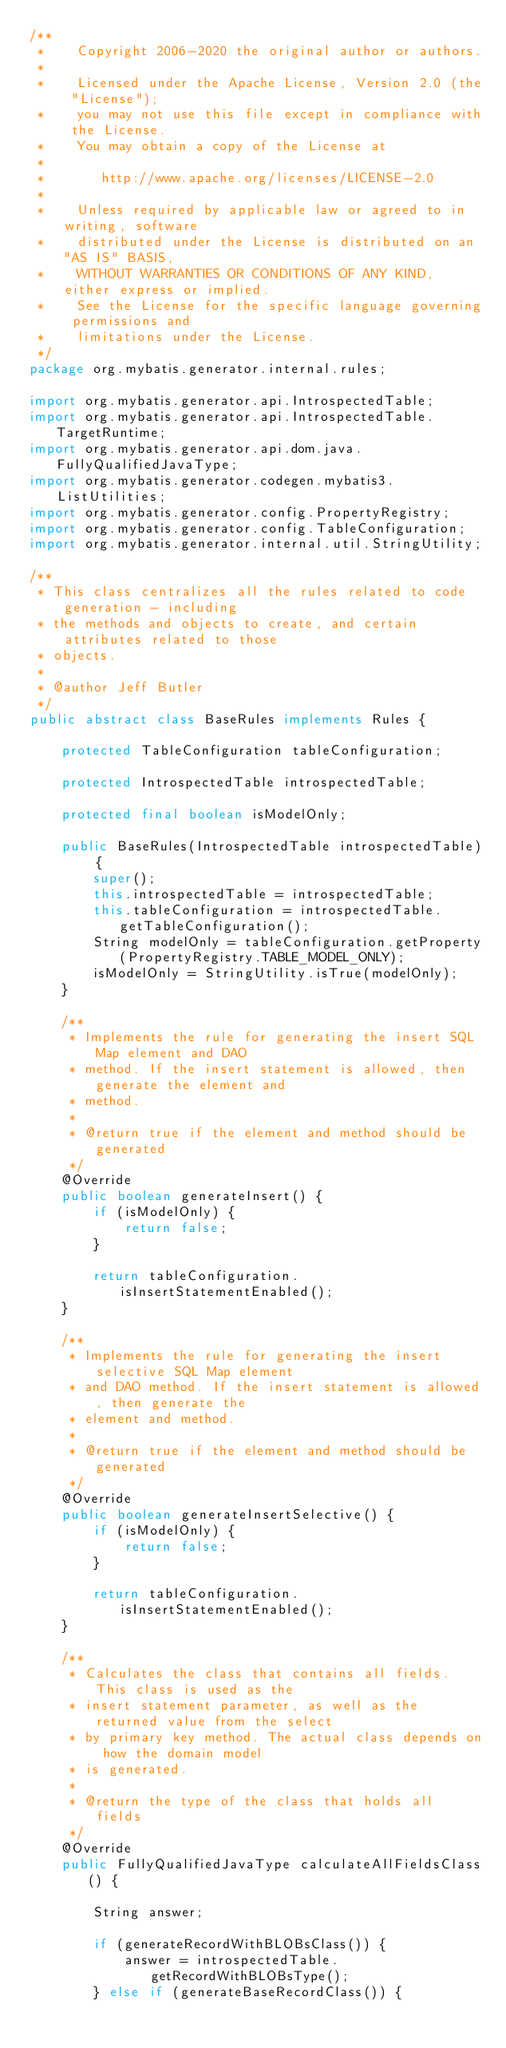Convert code to text. <code><loc_0><loc_0><loc_500><loc_500><_Java_>/**
 *    Copyright 2006-2020 the original author or authors.
 *
 *    Licensed under the Apache License, Version 2.0 (the "License");
 *    you may not use this file except in compliance with the License.
 *    You may obtain a copy of the License at
 *
 *       http://www.apache.org/licenses/LICENSE-2.0
 *
 *    Unless required by applicable law or agreed to in writing, software
 *    distributed under the License is distributed on an "AS IS" BASIS,
 *    WITHOUT WARRANTIES OR CONDITIONS OF ANY KIND, either express or implied.
 *    See the License for the specific language governing permissions and
 *    limitations under the License.
 */
package org.mybatis.generator.internal.rules;

import org.mybatis.generator.api.IntrospectedTable;
import org.mybatis.generator.api.IntrospectedTable.TargetRuntime;
import org.mybatis.generator.api.dom.java.FullyQualifiedJavaType;
import org.mybatis.generator.codegen.mybatis3.ListUtilities;
import org.mybatis.generator.config.PropertyRegistry;
import org.mybatis.generator.config.TableConfiguration;
import org.mybatis.generator.internal.util.StringUtility;

/**
 * This class centralizes all the rules related to code generation - including
 * the methods and objects to create, and certain attributes related to those
 * objects.
 * 
 * @author Jeff Butler
 */
public abstract class BaseRules implements Rules {

    protected TableConfiguration tableConfiguration;

    protected IntrospectedTable introspectedTable;

    protected final boolean isModelOnly;

    public BaseRules(IntrospectedTable introspectedTable) {
        super();
        this.introspectedTable = introspectedTable;
        this.tableConfiguration = introspectedTable.getTableConfiguration();
        String modelOnly = tableConfiguration.getProperty(PropertyRegistry.TABLE_MODEL_ONLY);
        isModelOnly = StringUtility.isTrue(modelOnly);
    }

    /**
     * Implements the rule for generating the insert SQL Map element and DAO
     * method. If the insert statement is allowed, then generate the element and
     * method.
     * 
     * @return true if the element and method should be generated
     */
    @Override
    public boolean generateInsert() {
        if (isModelOnly) {
            return false;
        }

        return tableConfiguration.isInsertStatementEnabled();
    }

    /**
     * Implements the rule for generating the insert selective SQL Map element
     * and DAO method. If the insert statement is allowed, then generate the
     * element and method.
     * 
     * @return true if the element and method should be generated
     */
    @Override
    public boolean generateInsertSelective() {
        if (isModelOnly) {
            return false;
        }

        return tableConfiguration.isInsertStatementEnabled();
    }

    /**
     * Calculates the class that contains all fields. This class is used as the
     * insert statement parameter, as well as the returned value from the select
     * by primary key method. The actual class depends on how the domain model
     * is generated.
     * 
     * @return the type of the class that holds all fields
     */
    @Override
    public FullyQualifiedJavaType calculateAllFieldsClass() {

        String answer;

        if (generateRecordWithBLOBsClass()) {
            answer = introspectedTable.getRecordWithBLOBsType();
        } else if (generateBaseRecordClass()) {</code> 